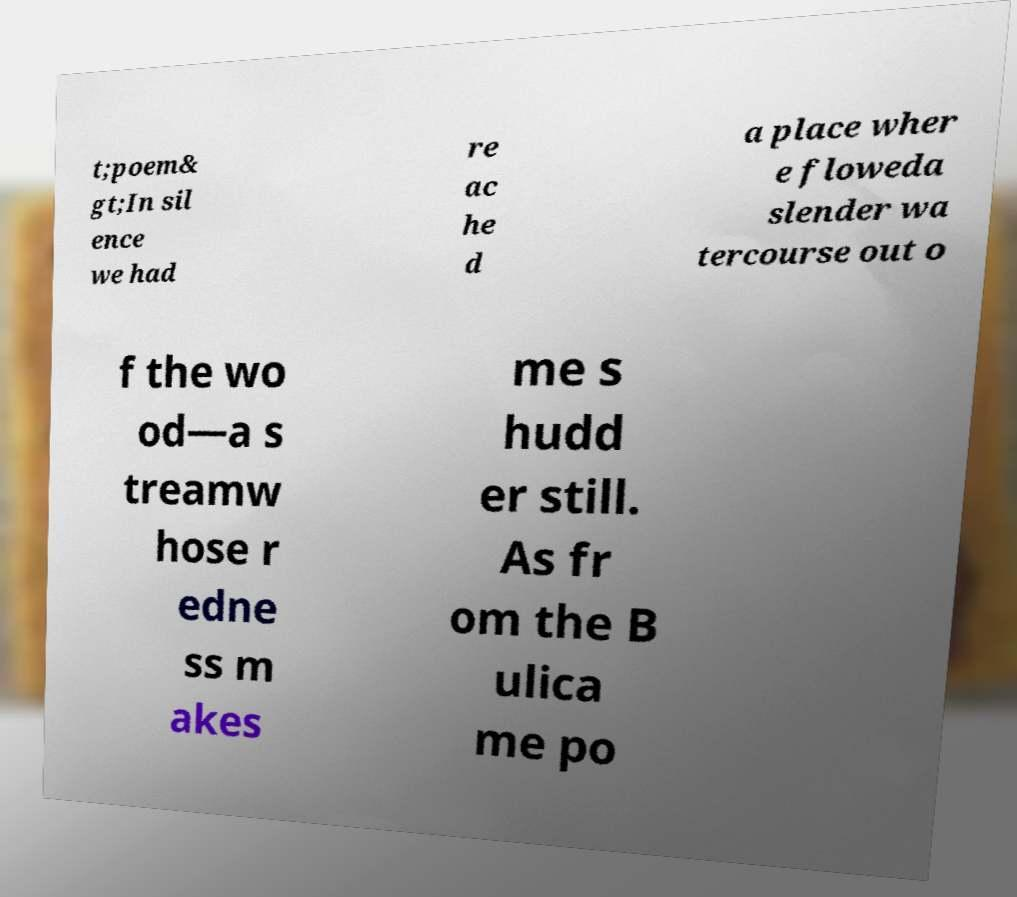Please identify and transcribe the text found in this image. t;poem& gt;In sil ence we had re ac he d a place wher e floweda slender wa tercourse out o f the wo od—a s treamw hose r edne ss m akes me s hudd er still. As fr om the B ulica me po 